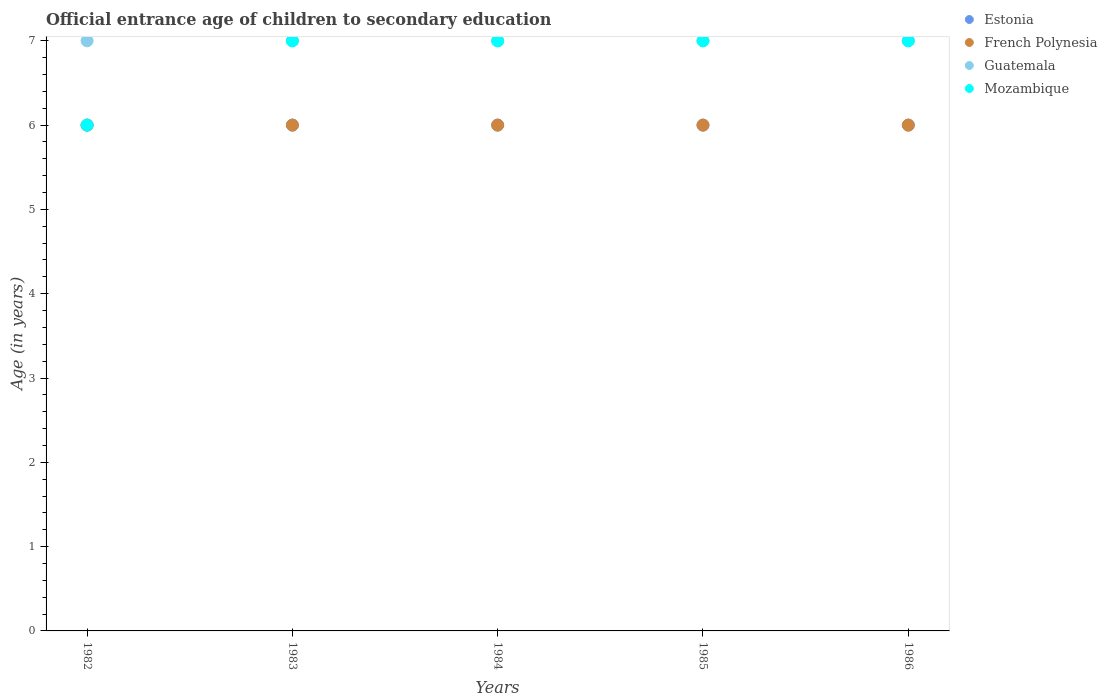What is the secondary school starting age of children in Mozambique in 1983?
Ensure brevity in your answer.  7. What is the total secondary school starting age of children in Mozambique in the graph?
Keep it short and to the point. 34. What is the difference between the secondary school starting age of children in Estonia in 1982 and that in 1986?
Your response must be concise. 0. What is the difference between the secondary school starting age of children in Guatemala in 1984 and the secondary school starting age of children in Mozambique in 1983?
Your answer should be compact. 0. What is the average secondary school starting age of children in Mozambique per year?
Give a very brief answer. 6.8. In how many years, is the secondary school starting age of children in Guatemala greater than 2.2 years?
Make the answer very short. 5. What is the ratio of the secondary school starting age of children in Guatemala in 1982 to that in 1985?
Provide a succinct answer. 1. What is the difference between the highest and the second highest secondary school starting age of children in Estonia?
Give a very brief answer. 0. What is the difference between the highest and the lowest secondary school starting age of children in French Polynesia?
Offer a very short reply. 0. In how many years, is the secondary school starting age of children in French Polynesia greater than the average secondary school starting age of children in French Polynesia taken over all years?
Offer a terse response. 0. Is it the case that in every year, the sum of the secondary school starting age of children in Mozambique and secondary school starting age of children in Estonia  is greater than the sum of secondary school starting age of children in French Polynesia and secondary school starting age of children in Guatemala?
Make the answer very short. No. Does the secondary school starting age of children in Estonia monotonically increase over the years?
Ensure brevity in your answer.  No. Is the secondary school starting age of children in Guatemala strictly greater than the secondary school starting age of children in Mozambique over the years?
Your answer should be compact. No. Is the secondary school starting age of children in French Polynesia strictly less than the secondary school starting age of children in Guatemala over the years?
Offer a very short reply. Yes. How many dotlines are there?
Your answer should be very brief. 4. What is the difference between two consecutive major ticks on the Y-axis?
Give a very brief answer. 1. Does the graph contain any zero values?
Your answer should be very brief. No. Does the graph contain grids?
Make the answer very short. No. How many legend labels are there?
Offer a terse response. 4. What is the title of the graph?
Your response must be concise. Official entrance age of children to secondary education. Does "Jordan" appear as one of the legend labels in the graph?
Offer a terse response. No. What is the label or title of the X-axis?
Provide a succinct answer. Years. What is the label or title of the Y-axis?
Provide a succinct answer. Age (in years). What is the Age (in years) of Estonia in 1982?
Make the answer very short. 6. What is the Age (in years) in French Polynesia in 1982?
Provide a short and direct response. 6. What is the Age (in years) of Guatemala in 1982?
Offer a very short reply. 7. What is the Age (in years) in Mozambique in 1982?
Your answer should be very brief. 6. What is the Age (in years) in Estonia in 1983?
Your answer should be very brief. 6. What is the Age (in years) of French Polynesia in 1983?
Offer a terse response. 6. What is the Age (in years) in Guatemala in 1983?
Offer a very short reply. 7. What is the Age (in years) in Mozambique in 1983?
Make the answer very short. 7. What is the Age (in years) of Estonia in 1984?
Your answer should be very brief. 6. What is the Age (in years) in Mozambique in 1984?
Your answer should be very brief. 7. What is the Age (in years) of Estonia in 1985?
Your response must be concise. 6. What is the Age (in years) in French Polynesia in 1985?
Keep it short and to the point. 6. What is the Age (in years) in Guatemala in 1985?
Make the answer very short. 7. What is the Age (in years) in French Polynesia in 1986?
Offer a very short reply. 6. Across all years, what is the maximum Age (in years) in Mozambique?
Give a very brief answer. 7. Across all years, what is the minimum Age (in years) in Estonia?
Your answer should be compact. 6. Across all years, what is the minimum Age (in years) of French Polynesia?
Your response must be concise. 6. Across all years, what is the minimum Age (in years) in Guatemala?
Provide a short and direct response. 7. Across all years, what is the minimum Age (in years) of Mozambique?
Make the answer very short. 6. What is the total Age (in years) of Estonia in the graph?
Make the answer very short. 30. What is the difference between the Age (in years) in French Polynesia in 1982 and that in 1983?
Offer a very short reply. 0. What is the difference between the Age (in years) in Mozambique in 1982 and that in 1983?
Your response must be concise. -1. What is the difference between the Age (in years) of French Polynesia in 1982 and that in 1984?
Offer a very short reply. 0. What is the difference between the Age (in years) in Guatemala in 1982 and that in 1984?
Offer a terse response. 0. What is the difference between the Age (in years) in Mozambique in 1982 and that in 1984?
Offer a terse response. -1. What is the difference between the Age (in years) of Estonia in 1982 and that in 1986?
Offer a very short reply. 0. What is the difference between the Age (in years) of French Polynesia in 1982 and that in 1986?
Provide a short and direct response. 0. What is the difference between the Age (in years) in Guatemala in 1982 and that in 1986?
Provide a succinct answer. 0. What is the difference between the Age (in years) in Mozambique in 1982 and that in 1986?
Make the answer very short. -1. What is the difference between the Age (in years) of Estonia in 1983 and that in 1984?
Offer a terse response. 0. What is the difference between the Age (in years) of Guatemala in 1983 and that in 1984?
Your answer should be compact. 0. What is the difference between the Age (in years) of Estonia in 1983 and that in 1985?
Provide a succinct answer. 0. What is the difference between the Age (in years) of French Polynesia in 1983 and that in 1985?
Provide a succinct answer. 0. What is the difference between the Age (in years) in Estonia in 1983 and that in 1986?
Make the answer very short. 0. What is the difference between the Age (in years) of French Polynesia in 1983 and that in 1986?
Provide a short and direct response. 0. What is the difference between the Age (in years) of Guatemala in 1983 and that in 1986?
Your answer should be compact. 0. What is the difference between the Age (in years) in Mozambique in 1983 and that in 1986?
Your response must be concise. 0. What is the difference between the Age (in years) in Estonia in 1984 and that in 1985?
Make the answer very short. 0. What is the difference between the Age (in years) of Estonia in 1984 and that in 1986?
Give a very brief answer. 0. What is the difference between the Age (in years) of French Polynesia in 1984 and that in 1986?
Offer a very short reply. 0. What is the difference between the Age (in years) of Estonia in 1985 and that in 1986?
Provide a succinct answer. 0. What is the difference between the Age (in years) of Estonia in 1982 and the Age (in years) of French Polynesia in 1983?
Provide a short and direct response. 0. What is the difference between the Age (in years) of Estonia in 1982 and the Age (in years) of Guatemala in 1983?
Make the answer very short. -1. What is the difference between the Age (in years) of Estonia in 1982 and the Age (in years) of Mozambique in 1983?
Provide a short and direct response. -1. What is the difference between the Age (in years) of Estonia in 1982 and the Age (in years) of Guatemala in 1984?
Provide a succinct answer. -1. What is the difference between the Age (in years) in Guatemala in 1982 and the Age (in years) in Mozambique in 1984?
Keep it short and to the point. 0. What is the difference between the Age (in years) in French Polynesia in 1982 and the Age (in years) in Mozambique in 1985?
Keep it short and to the point. -1. What is the difference between the Age (in years) in Guatemala in 1982 and the Age (in years) in Mozambique in 1985?
Provide a short and direct response. 0. What is the difference between the Age (in years) of Estonia in 1982 and the Age (in years) of French Polynesia in 1986?
Ensure brevity in your answer.  0. What is the difference between the Age (in years) of Estonia in 1982 and the Age (in years) of Guatemala in 1986?
Give a very brief answer. -1. What is the difference between the Age (in years) in Estonia in 1982 and the Age (in years) in Mozambique in 1986?
Your answer should be compact. -1. What is the difference between the Age (in years) in Guatemala in 1982 and the Age (in years) in Mozambique in 1986?
Ensure brevity in your answer.  0. What is the difference between the Age (in years) in Estonia in 1983 and the Age (in years) in French Polynesia in 1984?
Keep it short and to the point. 0. What is the difference between the Age (in years) of Estonia in 1983 and the Age (in years) of Mozambique in 1984?
Your answer should be very brief. -1. What is the difference between the Age (in years) in French Polynesia in 1983 and the Age (in years) in Mozambique in 1984?
Your response must be concise. -1. What is the difference between the Age (in years) of Guatemala in 1983 and the Age (in years) of Mozambique in 1984?
Your answer should be compact. 0. What is the difference between the Age (in years) of Estonia in 1983 and the Age (in years) of French Polynesia in 1985?
Make the answer very short. 0. What is the difference between the Age (in years) in Estonia in 1983 and the Age (in years) in Guatemala in 1985?
Provide a short and direct response. -1. What is the difference between the Age (in years) in Estonia in 1983 and the Age (in years) in Mozambique in 1985?
Offer a terse response. -1. What is the difference between the Age (in years) in French Polynesia in 1983 and the Age (in years) in Guatemala in 1985?
Keep it short and to the point. -1. What is the difference between the Age (in years) in French Polynesia in 1983 and the Age (in years) in Mozambique in 1985?
Offer a very short reply. -1. What is the difference between the Age (in years) in Estonia in 1983 and the Age (in years) in French Polynesia in 1986?
Provide a short and direct response. 0. What is the difference between the Age (in years) of Estonia in 1983 and the Age (in years) of Guatemala in 1986?
Your answer should be compact. -1. What is the difference between the Age (in years) in Guatemala in 1983 and the Age (in years) in Mozambique in 1986?
Ensure brevity in your answer.  0. What is the difference between the Age (in years) in Estonia in 1984 and the Age (in years) in French Polynesia in 1985?
Give a very brief answer. 0. What is the difference between the Age (in years) of Estonia in 1984 and the Age (in years) of French Polynesia in 1986?
Keep it short and to the point. 0. What is the difference between the Age (in years) of Estonia in 1984 and the Age (in years) of Mozambique in 1986?
Provide a short and direct response. -1. What is the difference between the Age (in years) in French Polynesia in 1984 and the Age (in years) in Guatemala in 1986?
Offer a very short reply. -1. What is the difference between the Age (in years) of French Polynesia in 1984 and the Age (in years) of Mozambique in 1986?
Provide a short and direct response. -1. What is the difference between the Age (in years) in Estonia in 1985 and the Age (in years) in Guatemala in 1986?
Ensure brevity in your answer.  -1. What is the difference between the Age (in years) in Estonia in 1985 and the Age (in years) in Mozambique in 1986?
Your answer should be very brief. -1. What is the difference between the Age (in years) in French Polynesia in 1985 and the Age (in years) in Mozambique in 1986?
Give a very brief answer. -1. What is the difference between the Age (in years) of Guatemala in 1985 and the Age (in years) of Mozambique in 1986?
Offer a terse response. 0. What is the average Age (in years) of Estonia per year?
Offer a terse response. 6. What is the average Age (in years) of Guatemala per year?
Offer a terse response. 7. In the year 1982, what is the difference between the Age (in years) of French Polynesia and Age (in years) of Guatemala?
Offer a terse response. -1. In the year 1983, what is the difference between the Age (in years) in Estonia and Age (in years) in French Polynesia?
Offer a terse response. 0. In the year 1983, what is the difference between the Age (in years) in Guatemala and Age (in years) in Mozambique?
Offer a very short reply. 0. In the year 1984, what is the difference between the Age (in years) in Estonia and Age (in years) in French Polynesia?
Give a very brief answer. 0. In the year 1984, what is the difference between the Age (in years) of French Polynesia and Age (in years) of Guatemala?
Your answer should be compact. -1. In the year 1985, what is the difference between the Age (in years) in Estonia and Age (in years) in French Polynesia?
Your answer should be compact. 0. In the year 1986, what is the difference between the Age (in years) of Estonia and Age (in years) of French Polynesia?
Your answer should be very brief. 0. In the year 1986, what is the difference between the Age (in years) of Estonia and Age (in years) of Mozambique?
Your response must be concise. -1. In the year 1986, what is the difference between the Age (in years) in French Polynesia and Age (in years) in Guatemala?
Your response must be concise. -1. In the year 1986, what is the difference between the Age (in years) in French Polynesia and Age (in years) in Mozambique?
Offer a very short reply. -1. In the year 1986, what is the difference between the Age (in years) of Guatemala and Age (in years) of Mozambique?
Your answer should be very brief. 0. What is the ratio of the Age (in years) in French Polynesia in 1982 to that in 1983?
Your response must be concise. 1. What is the ratio of the Age (in years) in Guatemala in 1982 to that in 1983?
Your answer should be compact. 1. What is the ratio of the Age (in years) in Estonia in 1982 to that in 1984?
Give a very brief answer. 1. What is the ratio of the Age (in years) in French Polynesia in 1982 to that in 1984?
Provide a short and direct response. 1. What is the ratio of the Age (in years) of Mozambique in 1982 to that in 1984?
Provide a succinct answer. 0.86. What is the ratio of the Age (in years) of Mozambique in 1982 to that in 1985?
Your answer should be compact. 0.86. What is the ratio of the Age (in years) of French Polynesia in 1982 to that in 1986?
Make the answer very short. 1. What is the ratio of the Age (in years) of Mozambique in 1982 to that in 1986?
Provide a succinct answer. 0.86. What is the ratio of the Age (in years) of Estonia in 1983 to that in 1984?
Your answer should be very brief. 1. What is the ratio of the Age (in years) in French Polynesia in 1983 to that in 1984?
Make the answer very short. 1. What is the ratio of the Age (in years) of Guatemala in 1983 to that in 1984?
Provide a succinct answer. 1. What is the ratio of the Age (in years) in French Polynesia in 1984 to that in 1985?
Offer a very short reply. 1. What is the ratio of the Age (in years) of Guatemala in 1984 to that in 1985?
Keep it short and to the point. 1. What is the ratio of the Age (in years) of Mozambique in 1984 to that in 1985?
Offer a very short reply. 1. What is the ratio of the Age (in years) of Estonia in 1984 to that in 1986?
Your response must be concise. 1. What is the ratio of the Age (in years) in French Polynesia in 1984 to that in 1986?
Make the answer very short. 1. What is the ratio of the Age (in years) in Mozambique in 1984 to that in 1986?
Your answer should be very brief. 1. What is the ratio of the Age (in years) of French Polynesia in 1985 to that in 1986?
Your answer should be compact. 1. What is the ratio of the Age (in years) in Mozambique in 1985 to that in 1986?
Provide a short and direct response. 1. What is the difference between the highest and the second highest Age (in years) of French Polynesia?
Offer a terse response. 0. What is the difference between the highest and the second highest Age (in years) of Guatemala?
Ensure brevity in your answer.  0. What is the difference between the highest and the second highest Age (in years) of Mozambique?
Offer a very short reply. 0. What is the difference between the highest and the lowest Age (in years) in Estonia?
Make the answer very short. 0. What is the difference between the highest and the lowest Age (in years) in Mozambique?
Offer a very short reply. 1. 